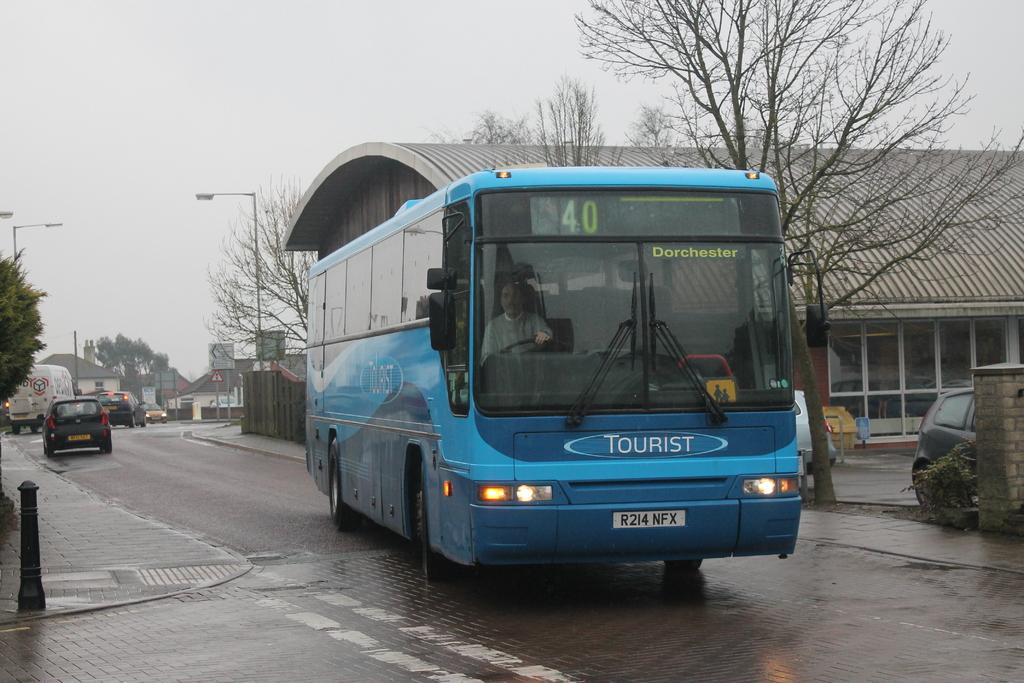<image>
Summarize the visual content of the image. city bus number 40 is driving on the road 